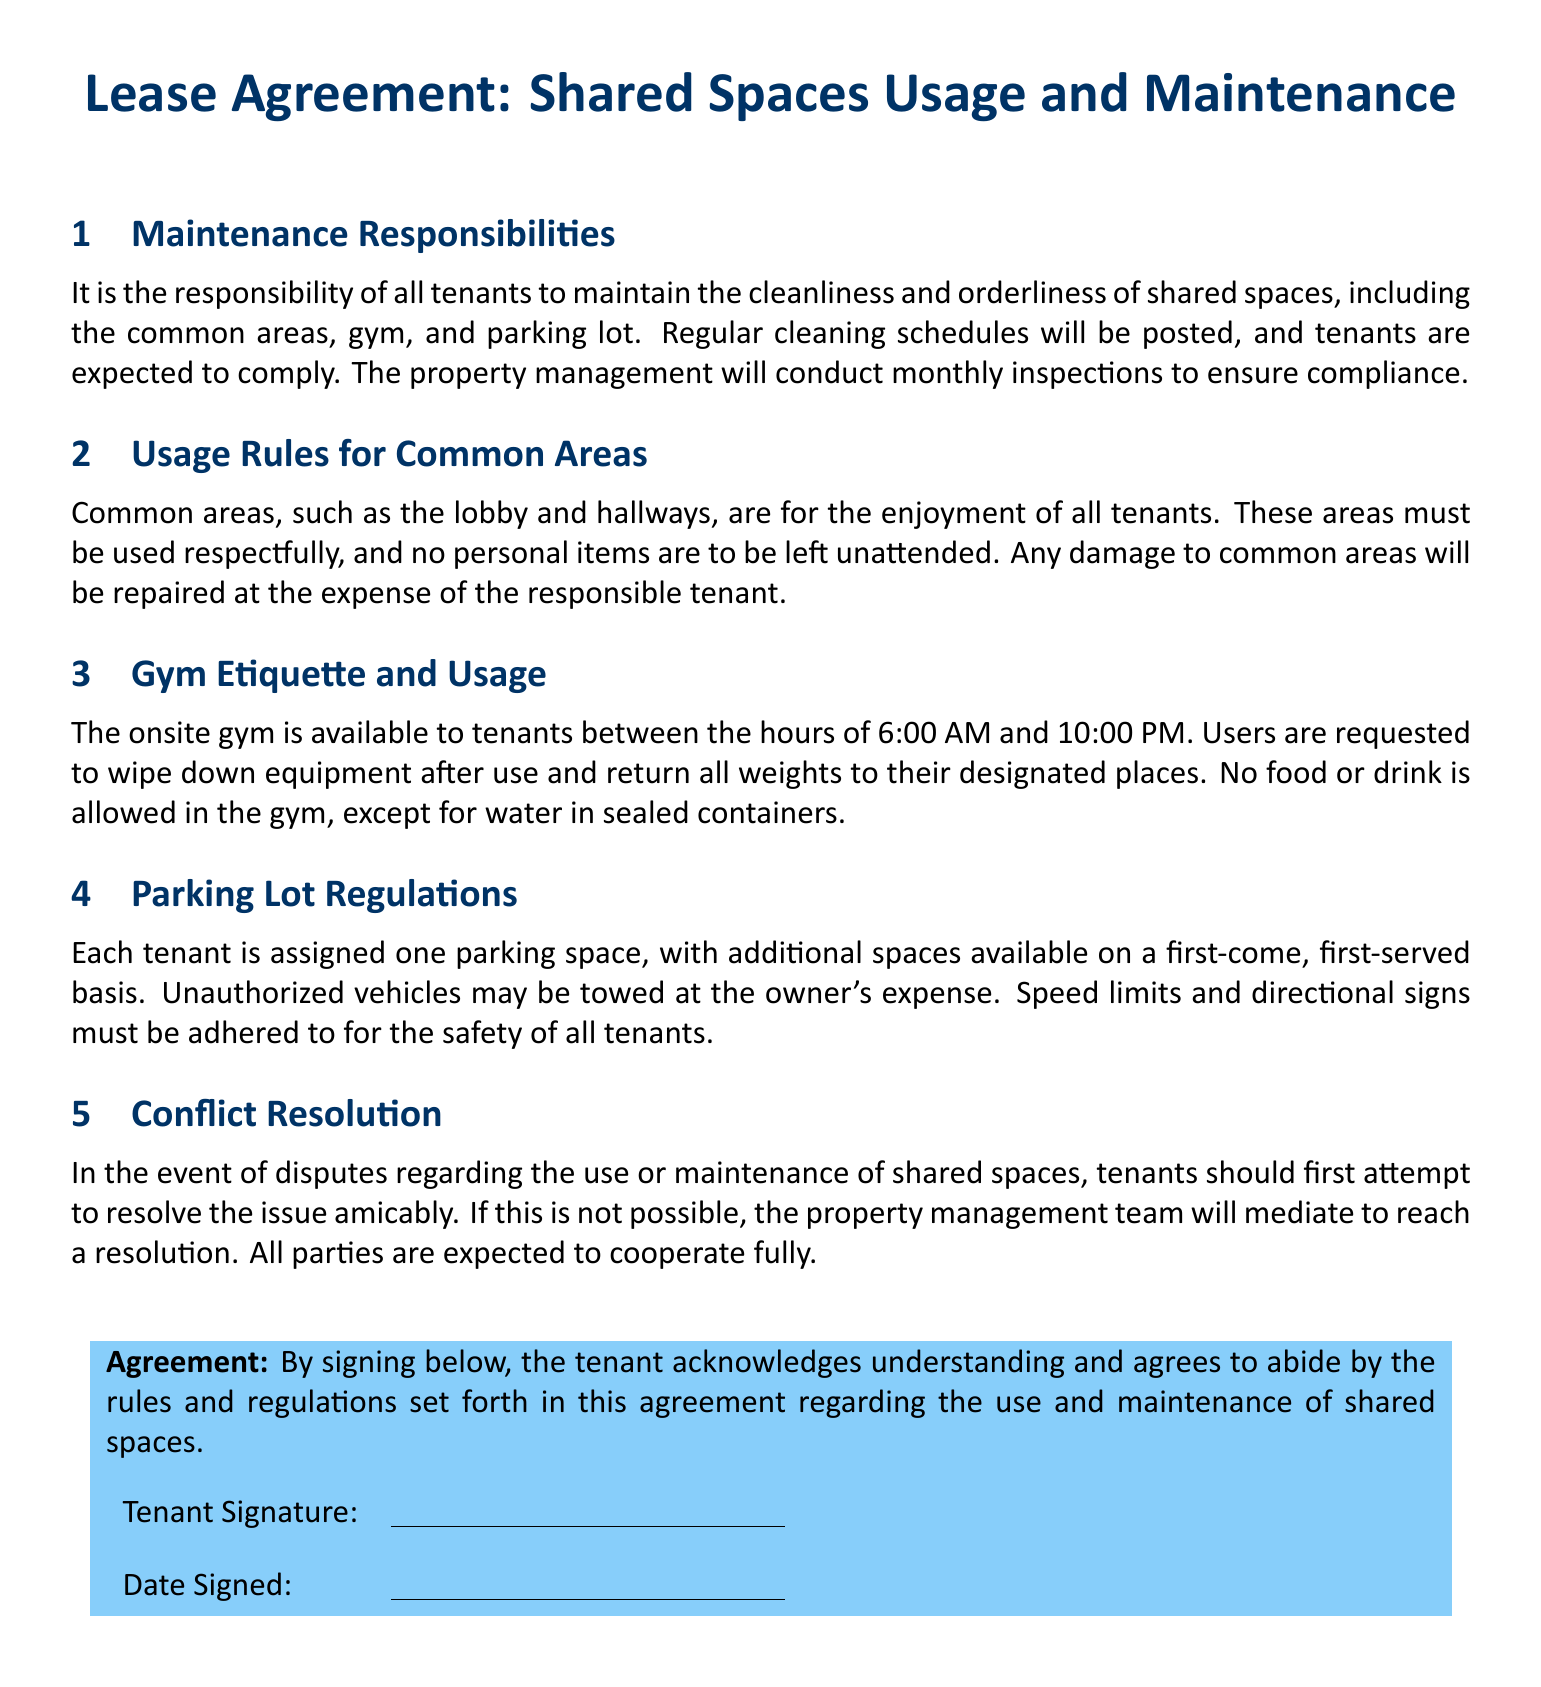What are the shared spaces mentioned in the agreement? The shared spaces include common areas, gym, and parking lot, as stated in the first section of the document.
Answer: common areas, gym, parking lot What is the gym's operating hours? The gym's operating hours are specified in the document as being available to tenants between certain times.
Answer: 6:00 AM and 10:00 PM How often will property management conduct inspections? The document indicates that property management will conduct inspections with a specific frequency for maintenance purposes.
Answer: monthly What must tenants do after using gym equipment? The gym etiquette section specifies an action required of tenants to maintain cleanliness after using the equipment.
Answer: wipe down equipment What happens in case of damage to common areas? The document outlines the procedure regarding damages occurring in shared spaces, identifying who is liable for repair costs.
Answer: at the expense of the responsible tenant What is the consequence for unauthorized vehicles in the parking lot? There is a specific action stated in the document regarding unauthorized vehicles in the parking lot.
Answer: towed at the owner's expense What should tenants do to resolve disputes regarding shared spaces? The document mentions an initial step regarding conflict resolution to address disputes among tenants.
Answer: attempt to resolve the issue amicably How many parking spaces are assigned to each tenant? The parking lot regulations section specifies how many parking spaces each tenant is entitled to.
Answer: one parking space 